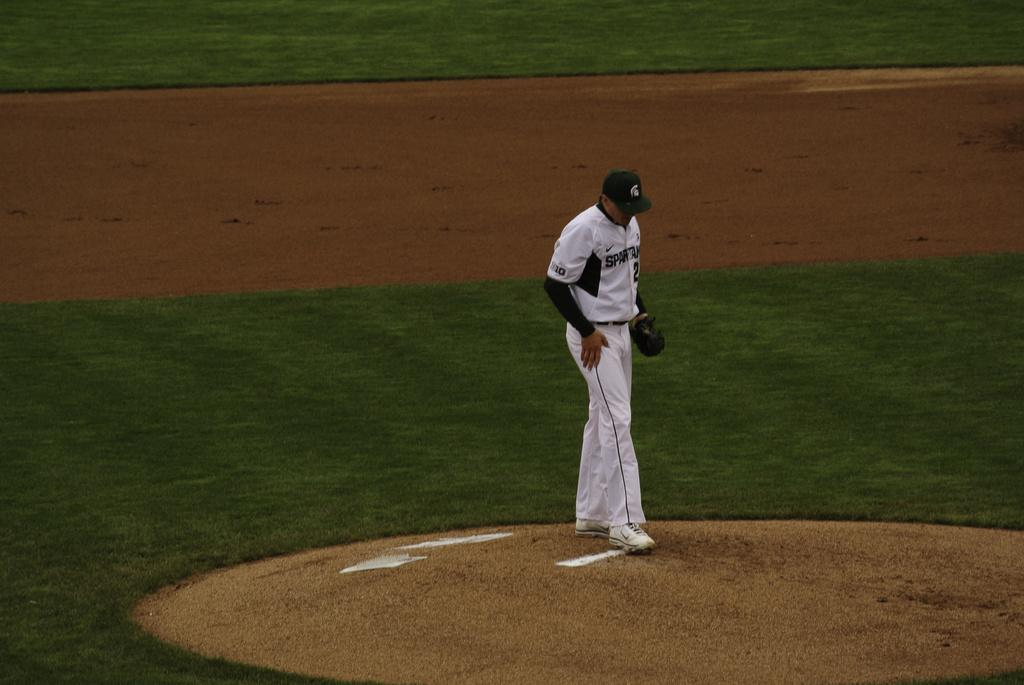Who is present in the image? There is a man in the image. What accessories is the man wearing? The man is wearing gloves and a cap. What type of terrain is visible in the image? There is grass and ground visible in the image. How many horses can be seen balancing on the observation deck in the image? There are no horses or observation decks present in the image. 